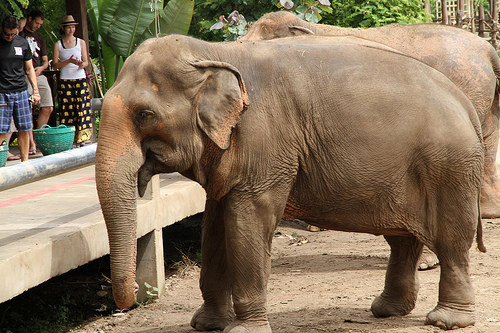Are the shorts khaki? Yes, the shorts are khaki in color. 